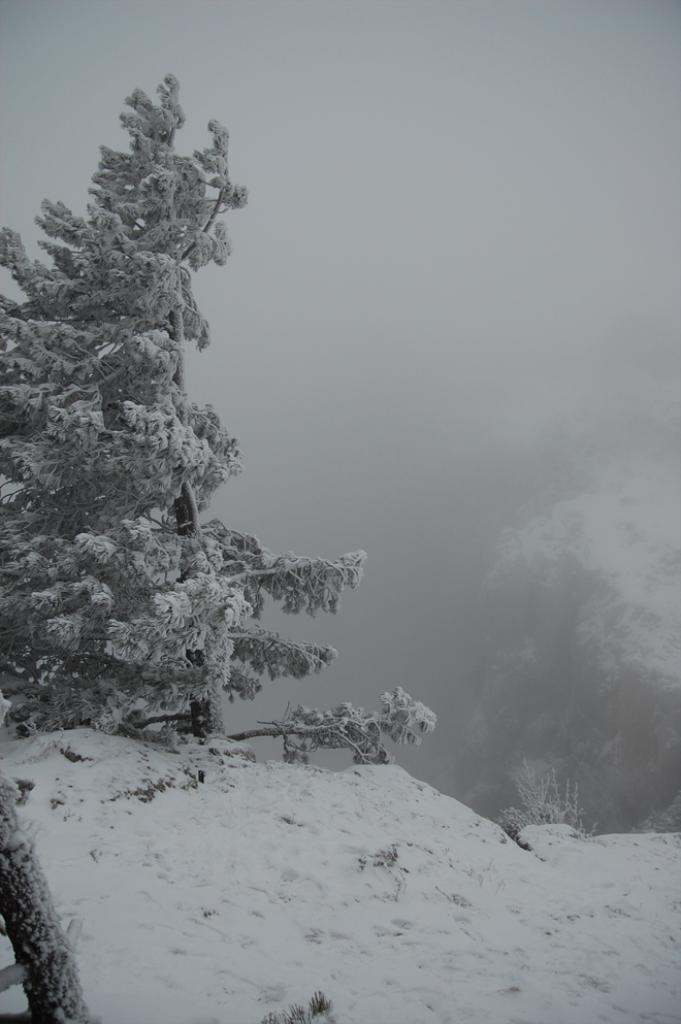What type of natural landform can be seen in the image? There are mountains in the image. What other natural elements are present in the image? There are trees in the image. What atmospheric condition is visible in the image? There is fog in the image. What part of the environment is visible in the image? The sky is visible in the image. Where might this image have been taken? The image may have been taken near the mountains, given their prominence in the image. How many books are stacked on the hands of the person in the image? There is no person or books present in the image; it features mountains, trees, fog, and the sky. 